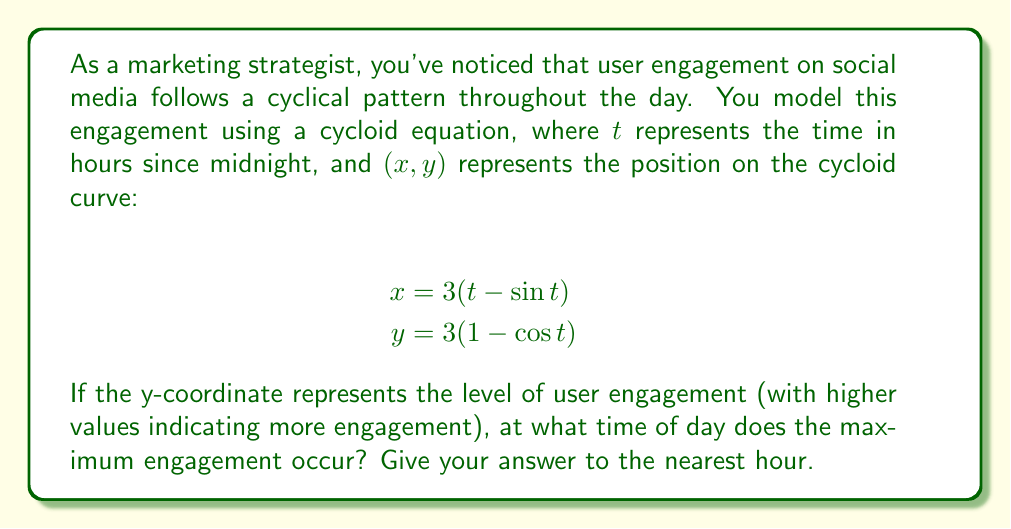Provide a solution to this math problem. To solve this problem, we need to follow these steps:

1) The maximum engagement occurs at the highest point of the cycloid. This happens when $y$ is at its maximum value.

2) In the equation $y = 3(1 - \cos t)$, $y$ is maximum when $\cos t$ is minimum.

3) We know that $\cos t$ has a minimum value of -1, which occurs when $t = \pi$ (in radians).

4) So, we need to solve the equation:
   
   $t - \sin t = \pi$

5) This is a transcendental equation and cannot be solved algebraically. We can use numerical methods or graphical solutions to approximate $t$.

6) Using a graphing calculator or computer software, we find that $t \approx 4.49$ radians.

7) To convert this to hours, we use the fact that $2\pi$ radians = 24 hours:

   $$\frac{4.49}{2\pi} * 24 \approx 17.16 \text{ hours}$$

8) Rounding to the nearest hour, we get 17 hours past midnight, which is 5:00 PM.
Answer: The maximum engagement occurs at approximately 5:00 PM (17:00). 